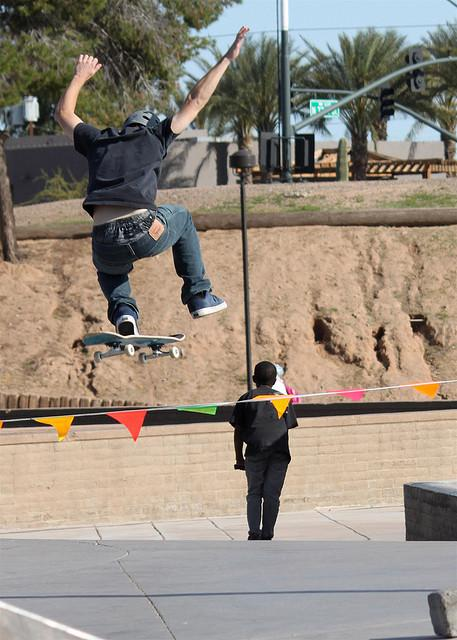In what setting is the skater skating? Please explain your reasoning. urban. The setting is urban. 